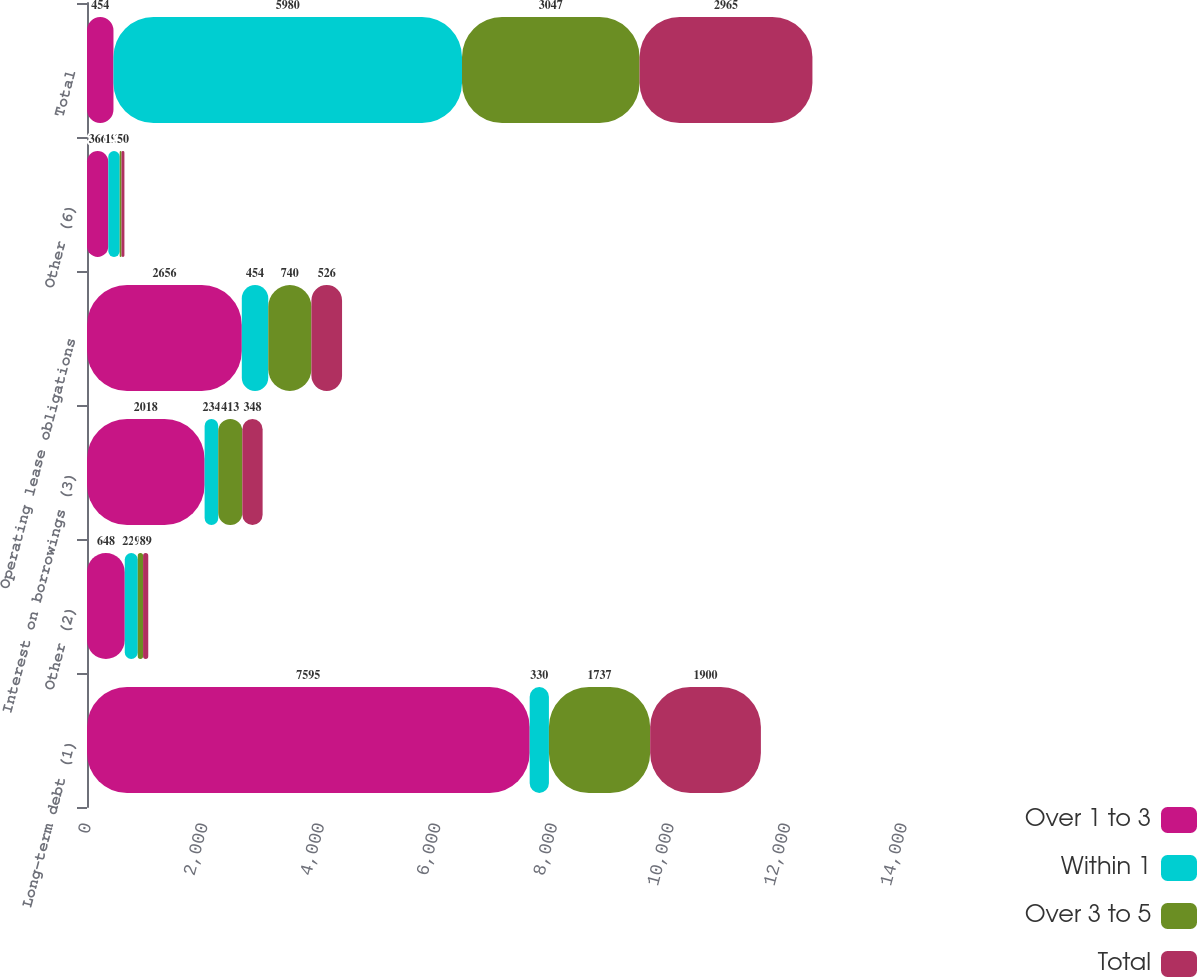Convert chart. <chart><loc_0><loc_0><loc_500><loc_500><stacked_bar_chart><ecel><fcel>Long-term debt (1)<fcel>Other (2)<fcel>Interest on borrowings (3)<fcel>Operating lease obligations<fcel>Other (6)<fcel>Total<nl><fcel>Over 1 to 3<fcel>7595<fcel>648<fcel>2018<fcel>2656<fcel>366<fcel>454<nl><fcel>Within 1<fcel>330<fcel>223<fcel>234<fcel>454<fcel>195<fcel>5980<nl><fcel>Over 3 to 5<fcel>1737<fcel>91<fcel>413<fcel>740<fcel>31<fcel>3047<nl><fcel>Total<fcel>1900<fcel>89<fcel>348<fcel>526<fcel>50<fcel>2965<nl></chart> 